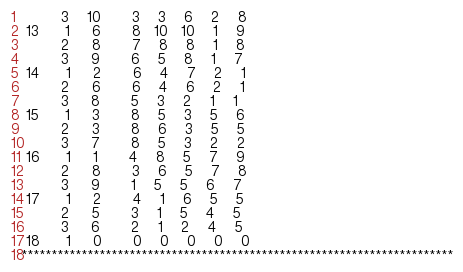Convert code to text. <code><loc_0><loc_0><loc_500><loc_500><_ObjectiveC_>         3    10       3    3    6    2    8
 13      1     6       8   10   10    1    9
         2     8       7    8    8    1    8
         3     9       6    5    8    1    7
 14      1     2       6    4    7    2    1
         2     6       6    4    6    2    1
         3     8       5    3    2    1    1
 15      1     3       8    5    3    5    6
         2     3       8    6    3    5    5
         3     7       8    5    3    2    2
 16      1     1       4    8    5    7    9
         2     8       3    6    5    7    8
         3     9       1    5    5    6    7
 17      1     2       4    1    6    5    5
         2     5       3    1    5    4    5
         3     6       2    1    2    4    5
 18      1     0       0    0    0    0    0
************************************************************************</code> 